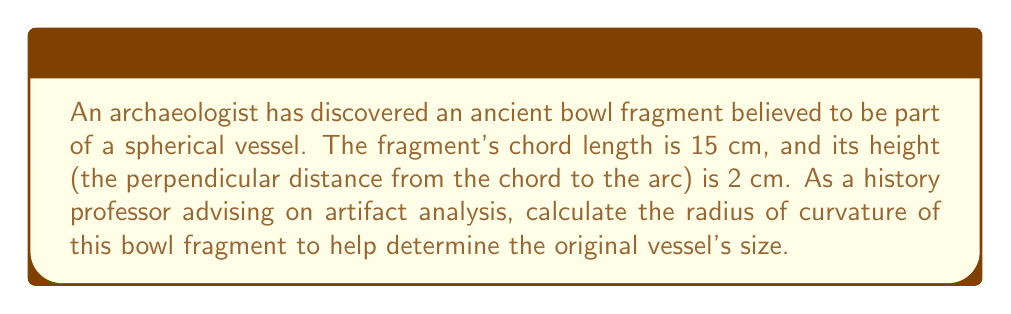Help me with this question. To calculate the radius of curvature of the spherical bowl fragment, we can use the formula for the radius of a circle given a chord length and height. This applies to our spherical fragment as any cross-section of a sphere is a circle.

Let's define our variables:
$c$ = chord length = 15 cm
$h$ = height = 2 cm
$R$ = radius of curvature (to be calculated)

The formula relating these variables is:

$$ R = \frac{c^2}{8h} + \frac{h}{2} $$

Now, let's substitute our known values:

$$ R = \frac{15^2}{8(2)} + \frac{2}{2} $$

$$ R = \frac{225}{16} + 1 $$

$$ R = 14.0625 + 1 $$

$$ R = 15.0625 \text{ cm} $$

This result gives us the radius of curvature of the bowl fragment, which is approximately 15.06 cm.

To verify, we can calculate the sagitta (height) using the radius and chord length:

$$ h = R - \sqrt{R^2 - (\frac{c}{2})^2} $$

$$ h = 15.0625 - \sqrt{15.0625^2 - (\frac{15}{2})^2} $$

$$ h \approx 2 \text{ cm} $$

This confirms our calculation is correct, as it matches the given height.
Answer: 15.0625 cm 